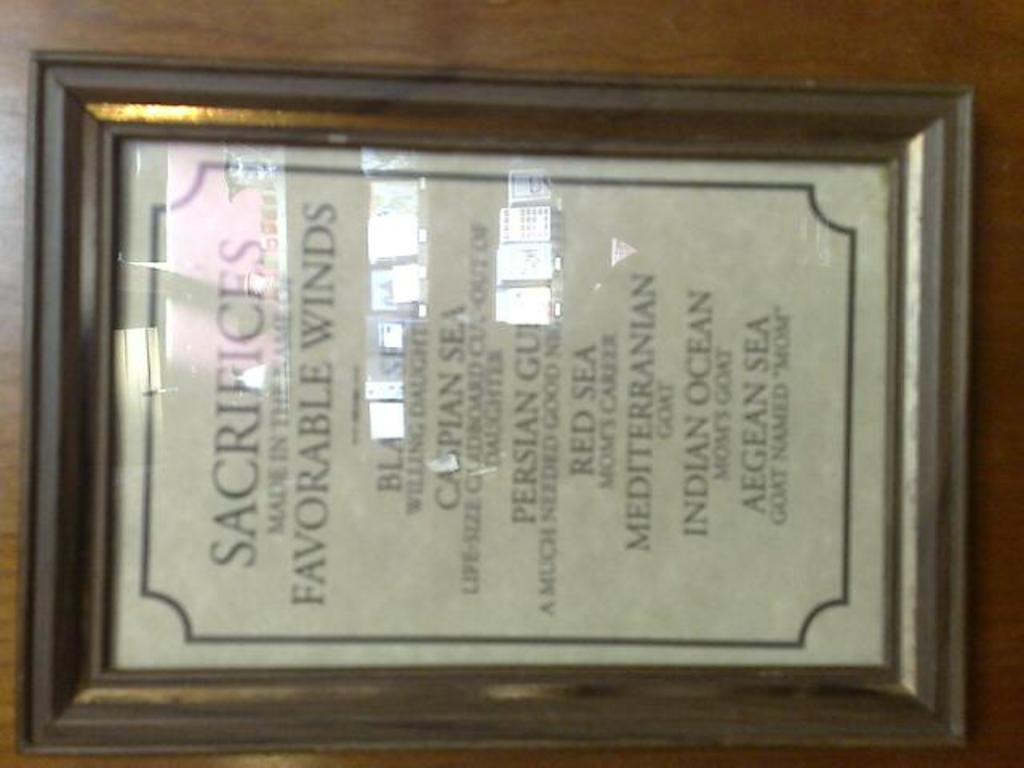<image>
Summarize the visual content of the image. A framed document discusses Sacrifices that were made. 